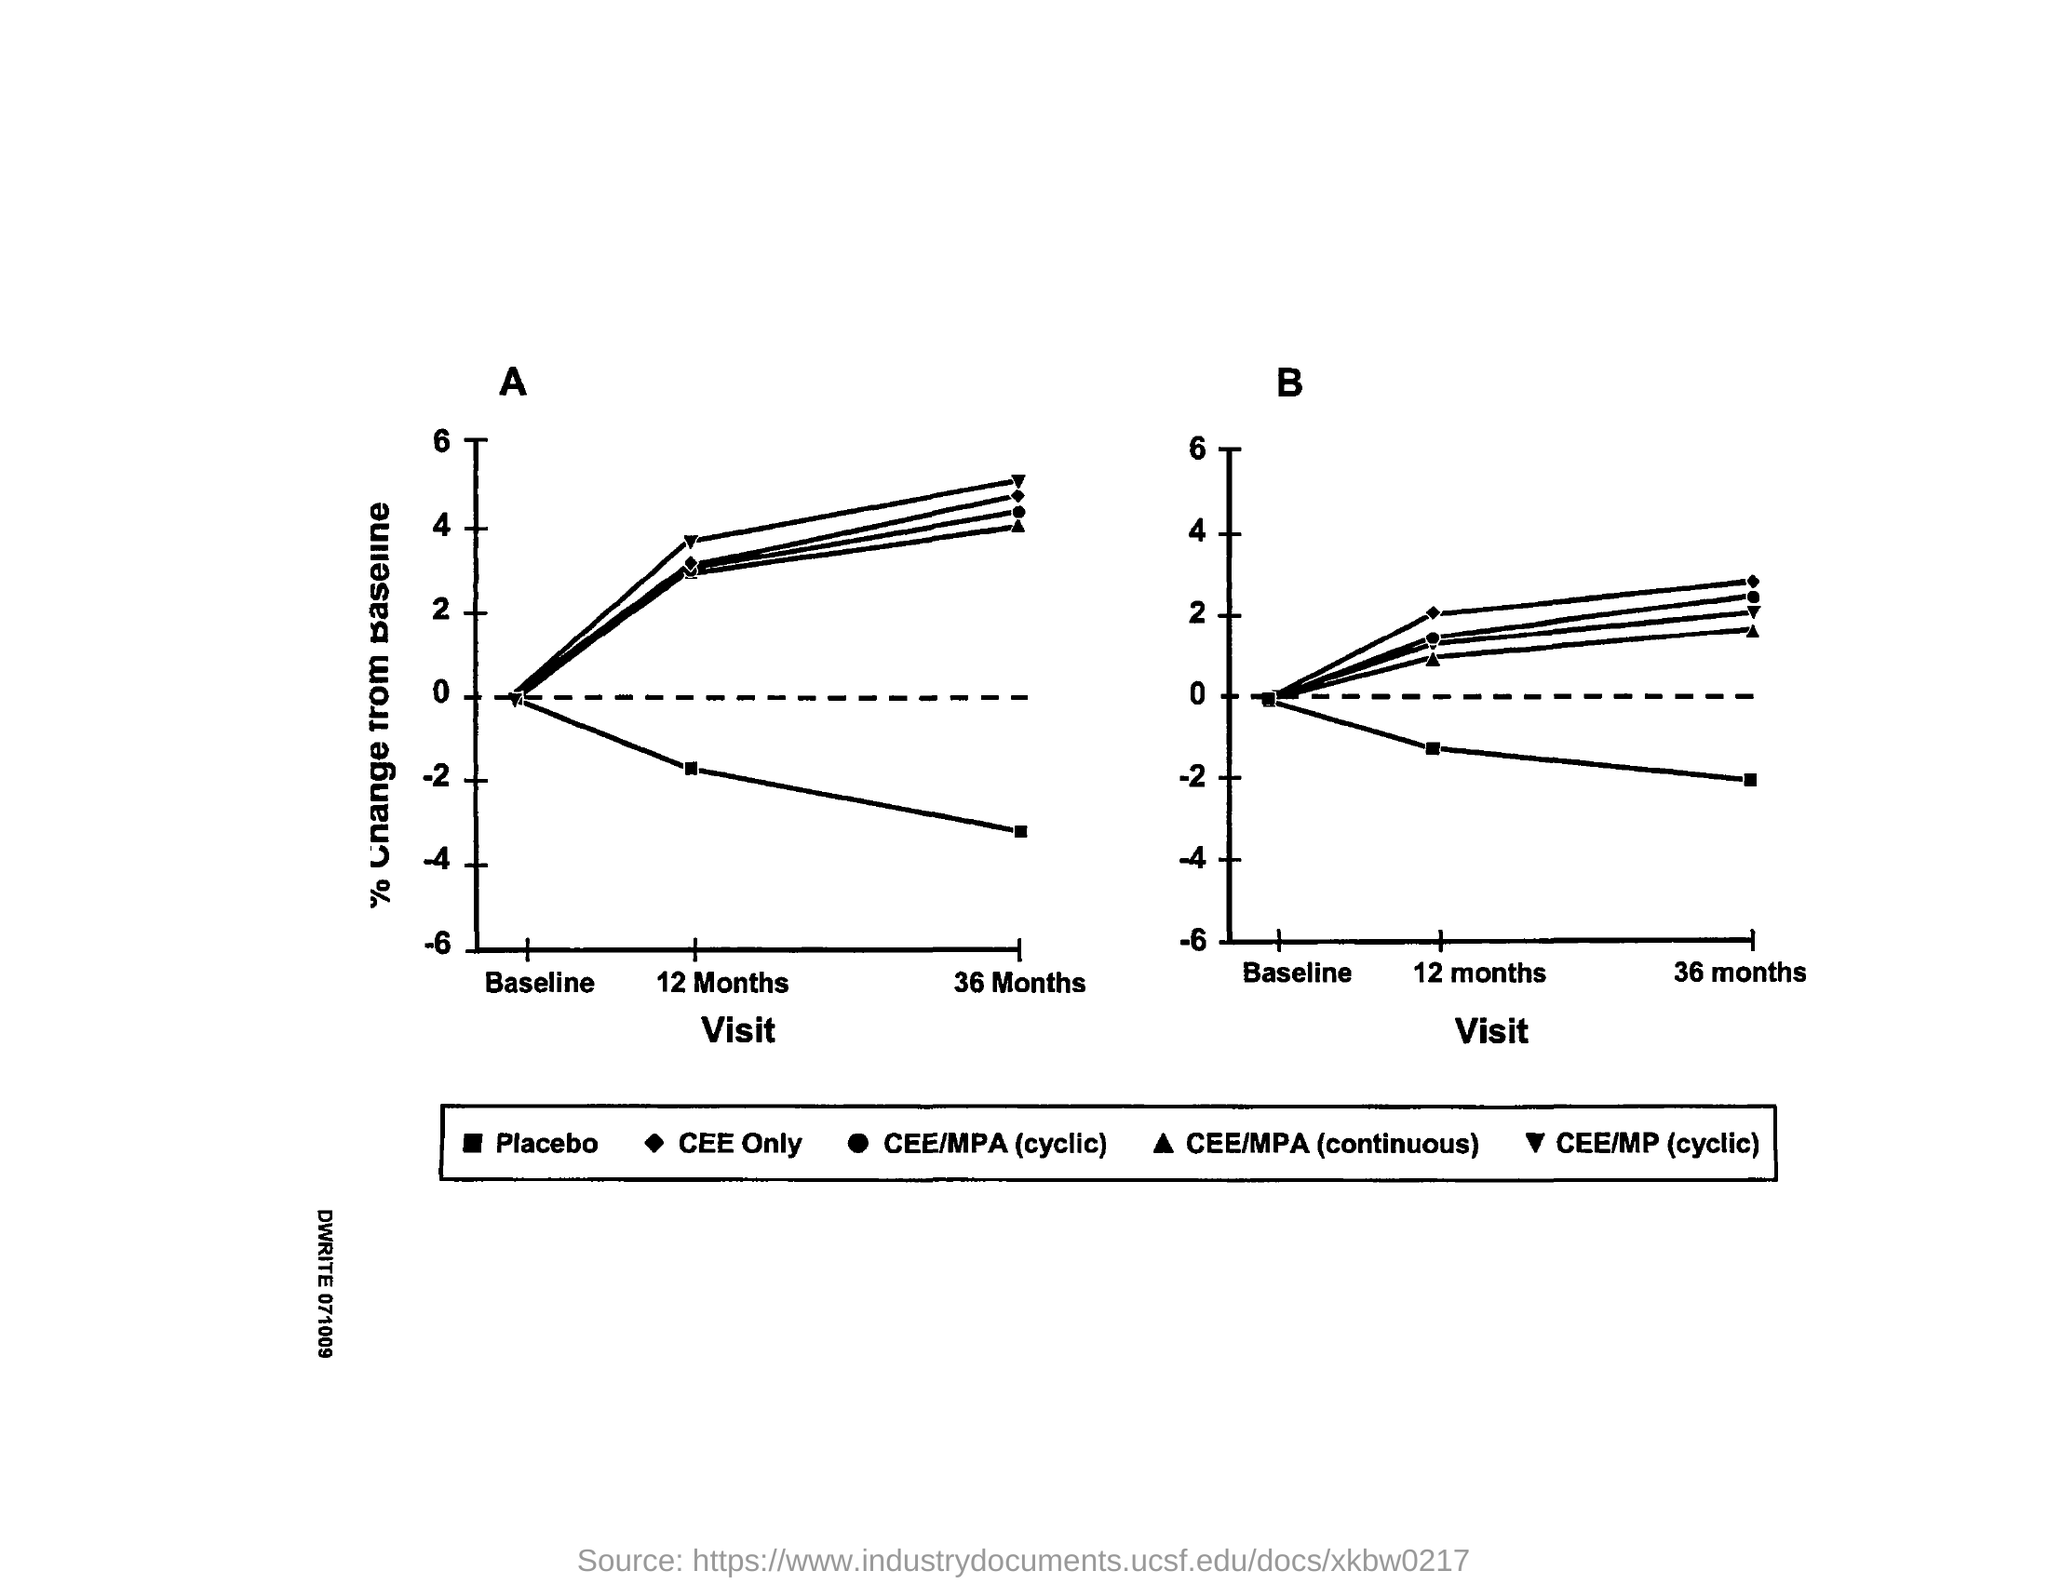What is plotted on the x-axis of both graphs?
Provide a succinct answer. Visit. Which alphabet represents the first graph?
Offer a very short reply. A. Which alphabet represents the second graph?
Give a very brief answer. B. 